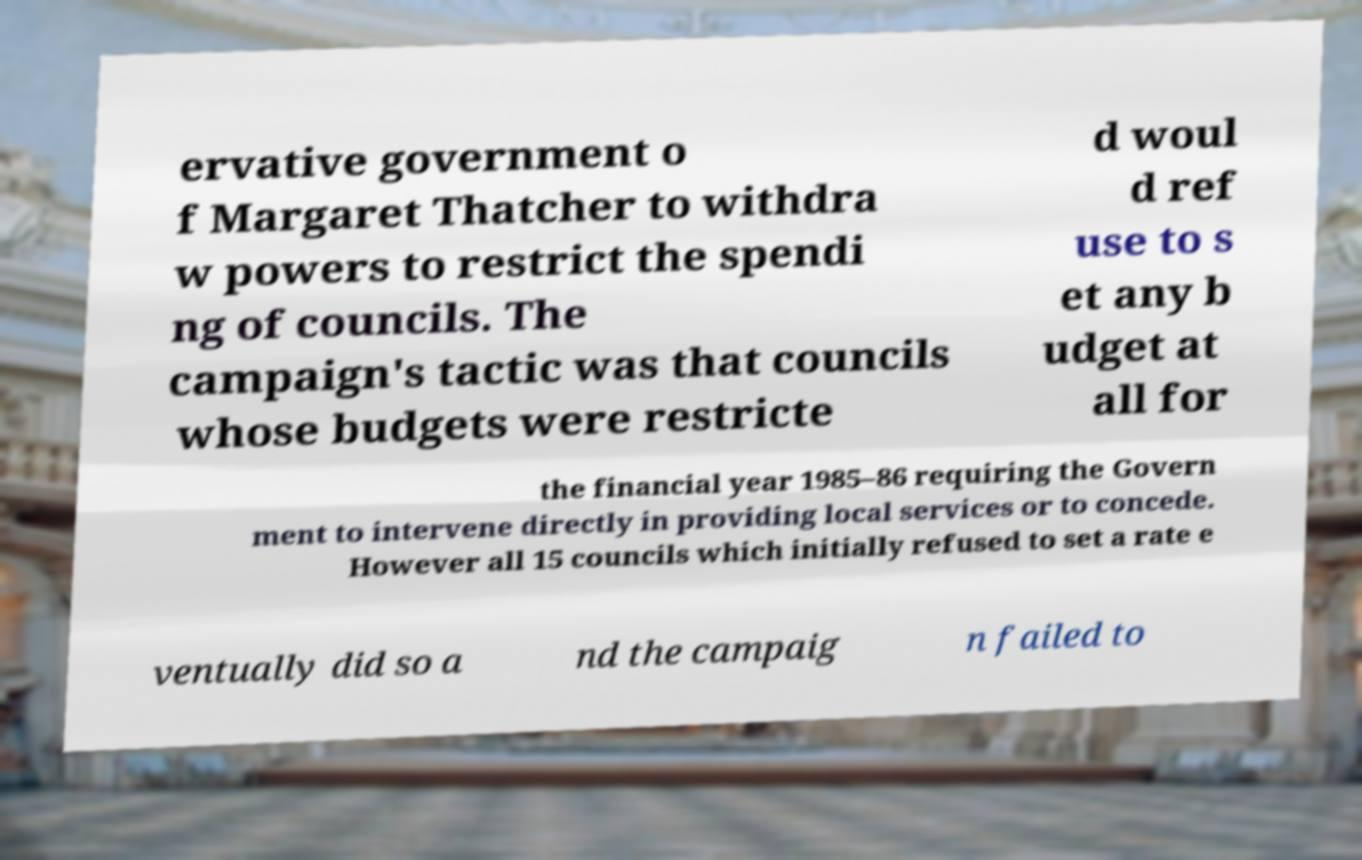Can you read and provide the text displayed in the image?This photo seems to have some interesting text. Can you extract and type it out for me? ervative government o f Margaret Thatcher to withdra w powers to restrict the spendi ng of councils. The campaign's tactic was that councils whose budgets were restricte d woul d ref use to s et any b udget at all for the financial year 1985–86 requiring the Govern ment to intervene directly in providing local services or to concede. However all 15 councils which initially refused to set a rate e ventually did so a nd the campaig n failed to 